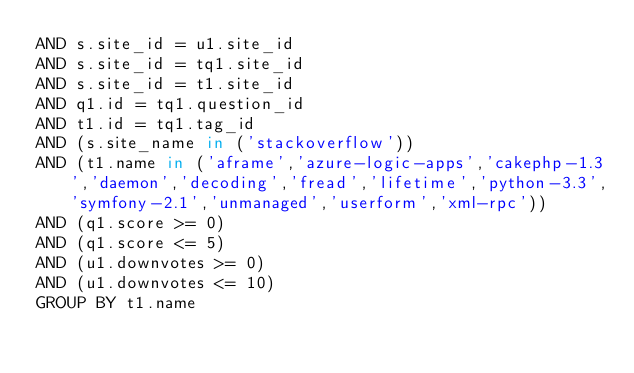<code> <loc_0><loc_0><loc_500><loc_500><_SQL_>AND s.site_id = u1.site_id
AND s.site_id = tq1.site_id
AND s.site_id = t1.site_id
AND q1.id = tq1.question_id
AND t1.id = tq1.tag_id
AND (s.site_name in ('stackoverflow'))
AND (t1.name in ('aframe','azure-logic-apps','cakephp-1.3','daemon','decoding','fread','lifetime','python-3.3','symfony-2.1','unmanaged','userform','xml-rpc'))
AND (q1.score >= 0)
AND (q1.score <= 5)
AND (u1.downvotes >= 0)
AND (u1.downvotes <= 10)
GROUP BY t1.name</code> 